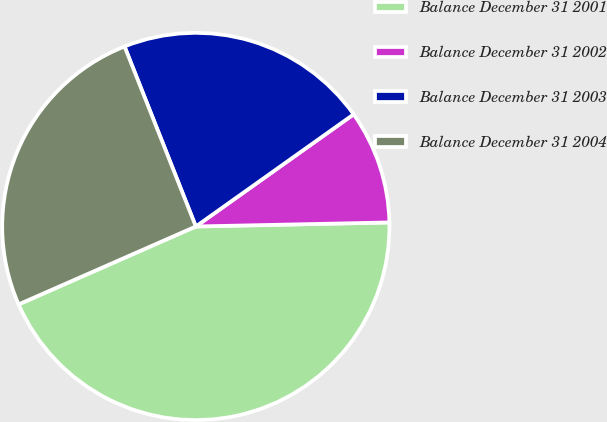Convert chart. <chart><loc_0><loc_0><loc_500><loc_500><pie_chart><fcel>Balance December 31 2001<fcel>Balance December 31 2002<fcel>Balance December 31 2003<fcel>Balance December 31 2004<nl><fcel>43.74%<fcel>9.5%<fcel>21.17%<fcel>25.59%<nl></chart> 